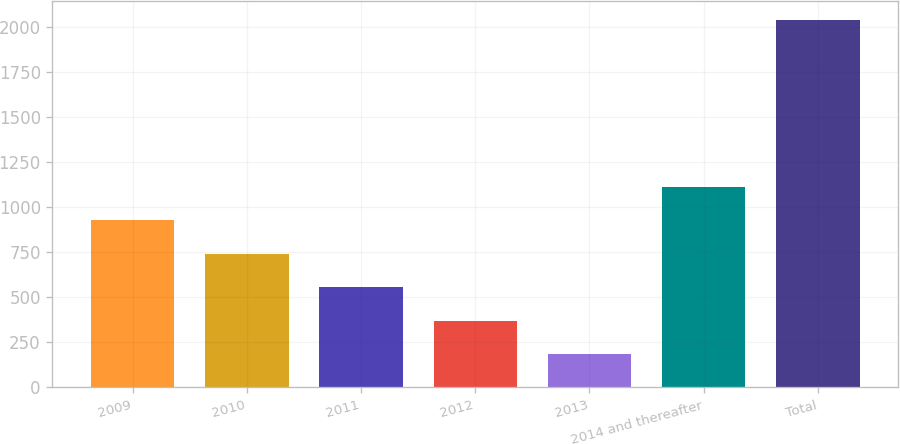Convert chart. <chart><loc_0><loc_0><loc_500><loc_500><bar_chart><fcel>2009<fcel>2010<fcel>2011<fcel>2012<fcel>2013<fcel>2014 and thereafter<fcel>Total<nl><fcel>925.46<fcel>740.02<fcel>554.58<fcel>369.14<fcel>183.7<fcel>1110.9<fcel>2038.1<nl></chart> 